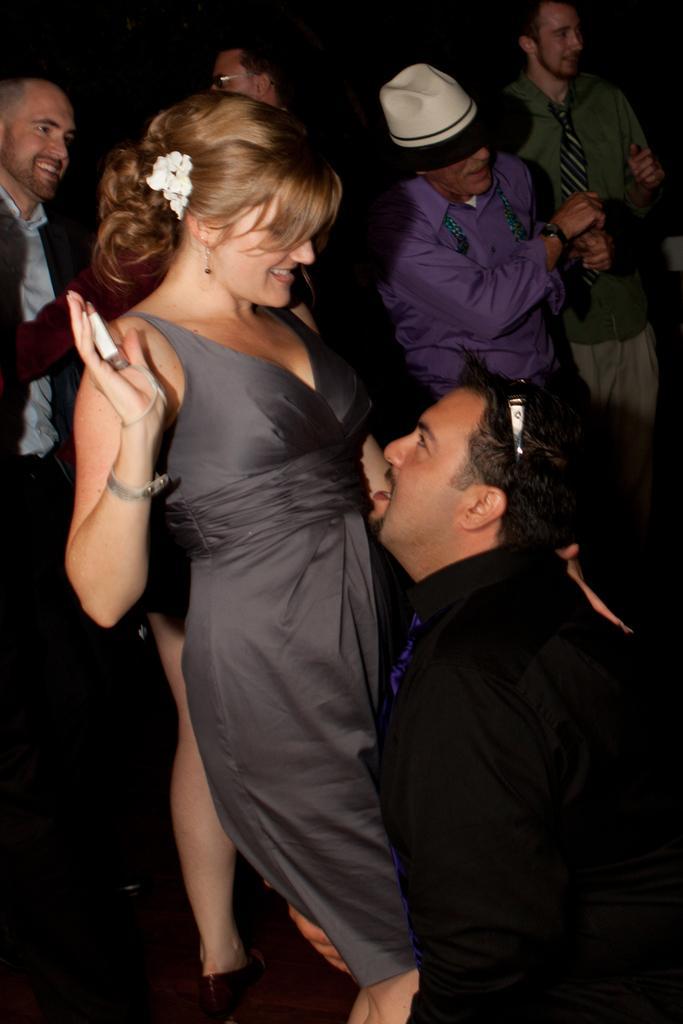Describe this image in one or two sentences. In this image there is a couple dancing behind them there are so many other people standing at their back and smiling. 